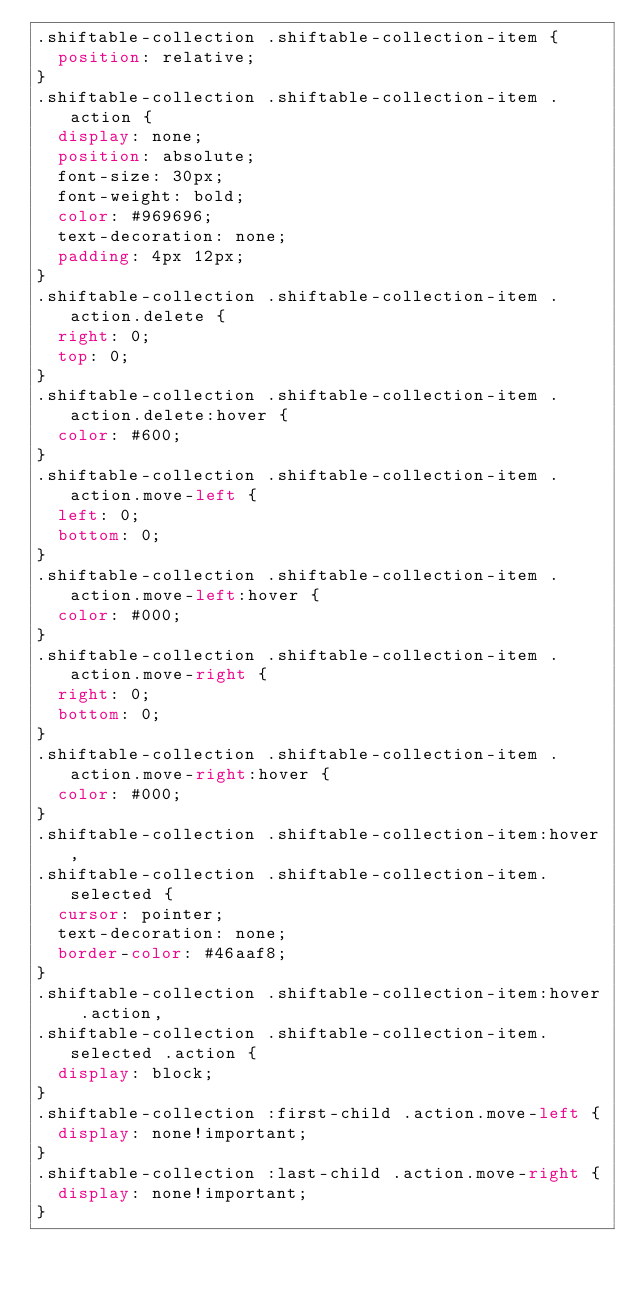<code> <loc_0><loc_0><loc_500><loc_500><_CSS_>.shiftable-collection .shiftable-collection-item {
  position: relative;
}
.shiftable-collection .shiftable-collection-item .action {
  display: none;
  position: absolute;
  font-size: 30px;
  font-weight: bold;
  color: #969696;
  text-decoration: none;
  padding: 4px 12px;
}
.shiftable-collection .shiftable-collection-item .action.delete {
  right: 0;
  top: 0;
}
.shiftable-collection .shiftable-collection-item .action.delete:hover {
  color: #600;
}
.shiftable-collection .shiftable-collection-item .action.move-left {
  left: 0;
  bottom: 0;
}
.shiftable-collection .shiftable-collection-item .action.move-left:hover {
  color: #000;
}
.shiftable-collection .shiftable-collection-item .action.move-right {
  right: 0;
  bottom: 0;
}
.shiftable-collection .shiftable-collection-item .action.move-right:hover {
  color: #000;
}
.shiftable-collection .shiftable-collection-item:hover,
.shiftable-collection .shiftable-collection-item.selected {
  cursor: pointer;
  text-decoration: none;
  border-color: #46aaf8;
}
.shiftable-collection .shiftable-collection-item:hover .action,
.shiftable-collection .shiftable-collection-item.selected .action {
  display: block;
}
.shiftable-collection :first-child .action.move-left {
  display: none!important;
}
.shiftable-collection :last-child .action.move-right {
  display: none!important;
}</code> 